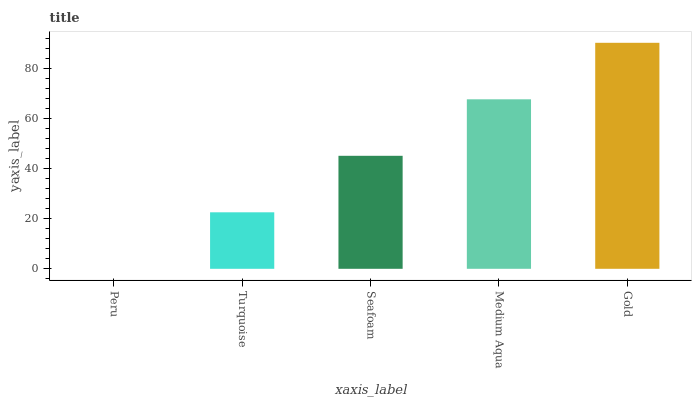Is Turquoise the minimum?
Answer yes or no. No. Is Turquoise the maximum?
Answer yes or no. No. Is Turquoise greater than Peru?
Answer yes or no. Yes. Is Peru less than Turquoise?
Answer yes or no. Yes. Is Peru greater than Turquoise?
Answer yes or no. No. Is Turquoise less than Peru?
Answer yes or no. No. Is Seafoam the high median?
Answer yes or no. Yes. Is Seafoam the low median?
Answer yes or no. Yes. Is Medium Aqua the high median?
Answer yes or no. No. Is Gold the low median?
Answer yes or no. No. 